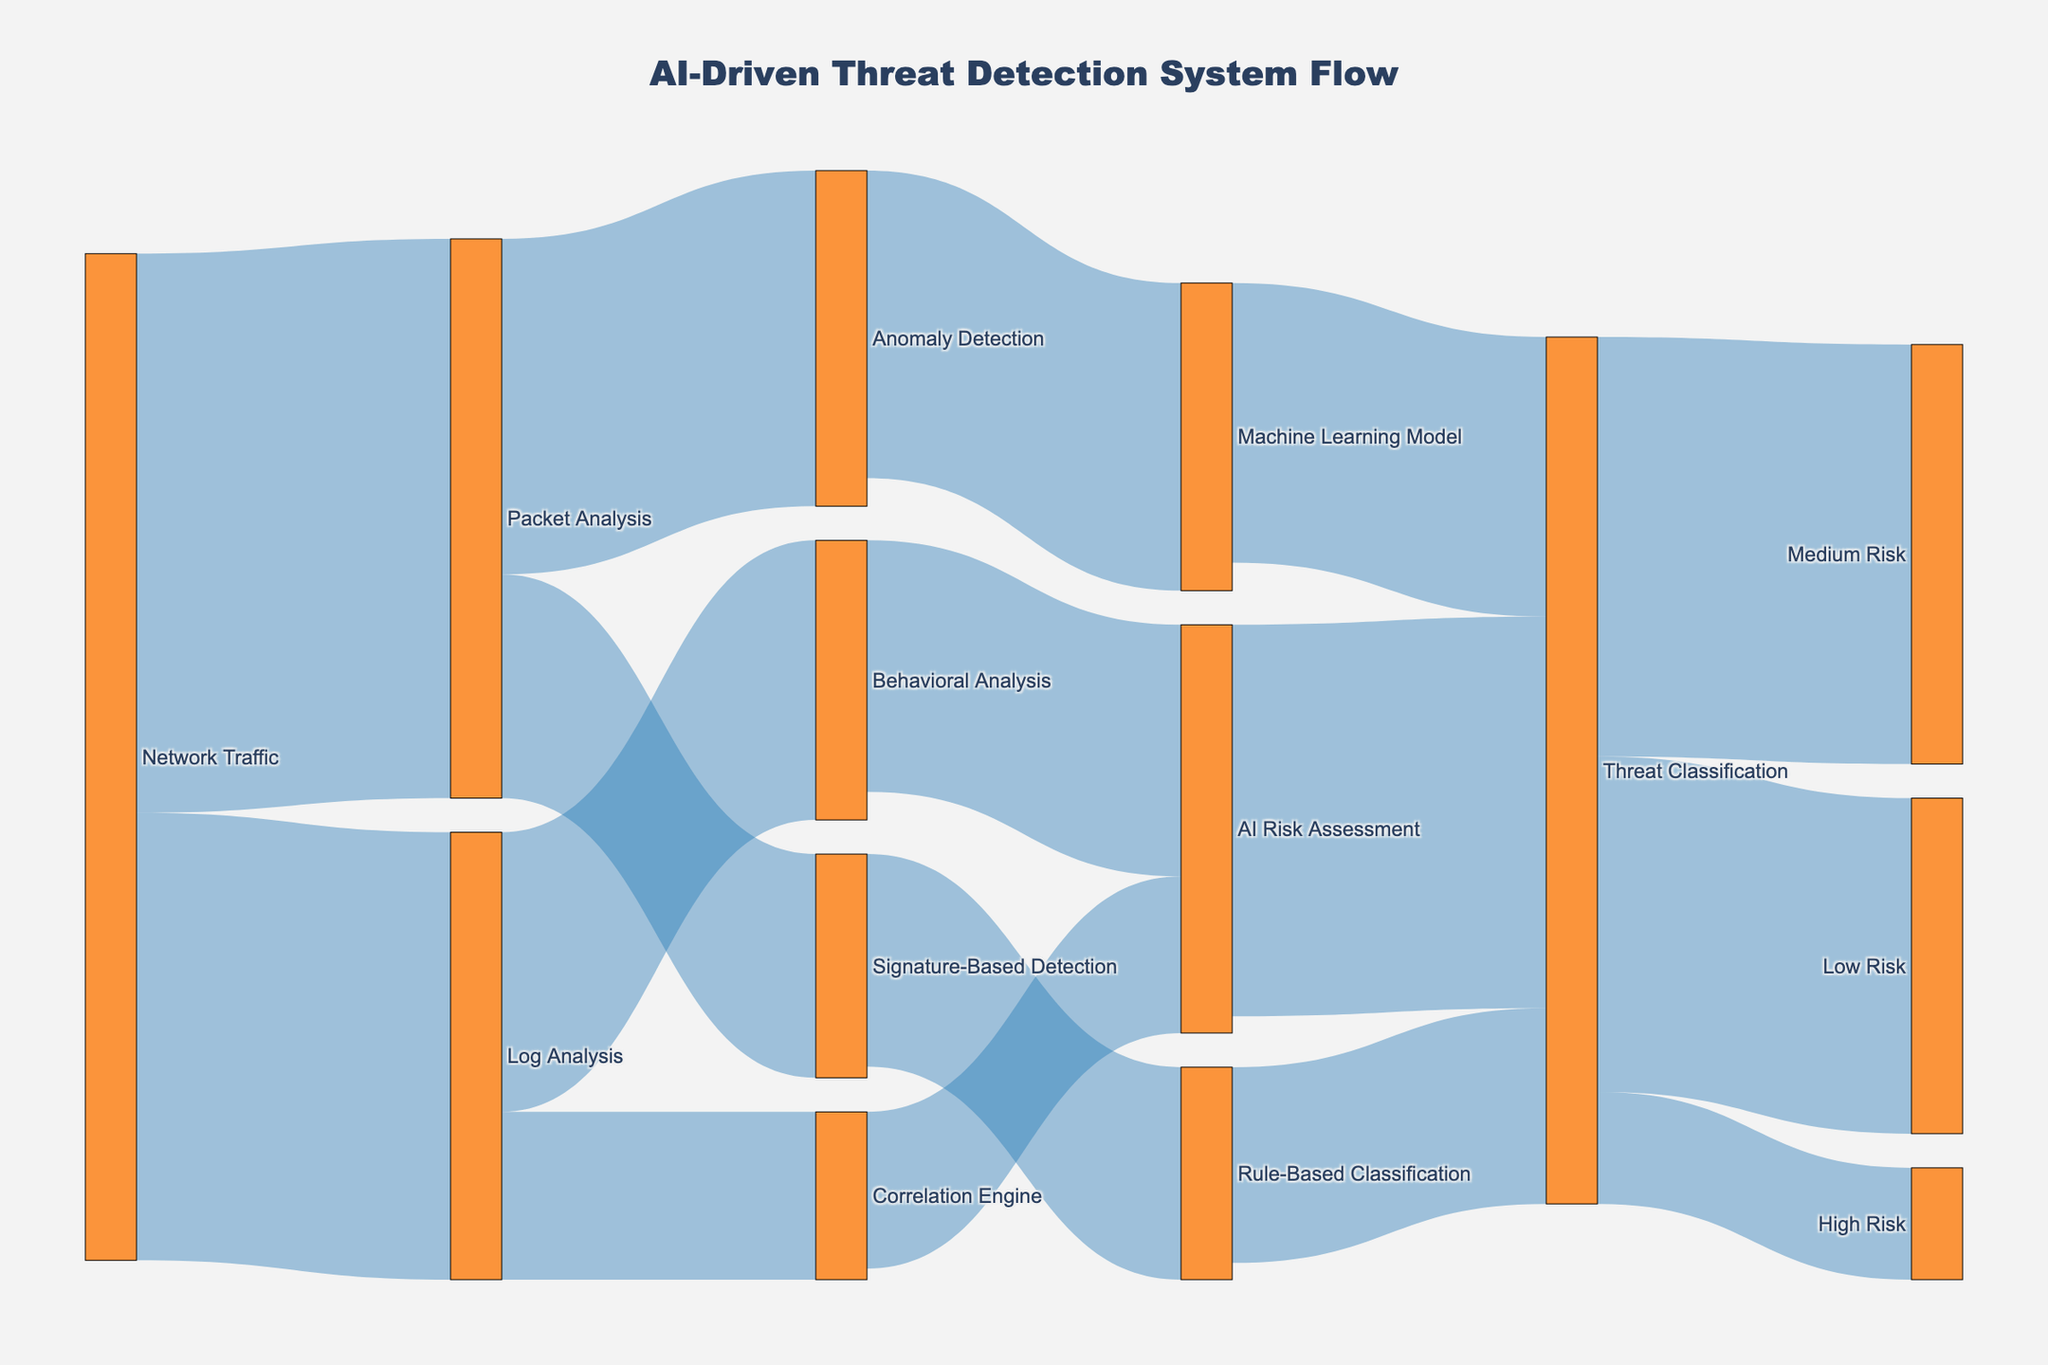What is the title of the diagram? The title is usually placed prominently at the top of the diagram. In this case, the title reads "AI-Driven Threat Detection System Flow."
Answer: AI-Driven Threat Detection System Flow Which data flow has the highest value entering the 'Threat Classification' node? Look at the arrows leading into the 'Threat Classification' node and compare their values. The highest value is 700 from 'AI Risk Assessment.'
Answer: Flow from AI Risk Assessment with value of 700 How many different types of threat classifications are there? Count the unique labels in the 'Threat Classification' node's outgoing flows. There are three classifications: 'Low Risk', 'Medium Risk', and 'High Risk.'
Answer: Three classifications What is the total value of flows originating from the 'Log Analysis' node? Sum the values of all outgoing flows from 'Log Analysis' (500 for 'Behavioral Analysis' and 300 for 'Correlation Engine'). The total is 800.
Answer: 800 Which path has the smallest value from initial input to final classification? Identify the paths and their values. One small path example is 'Log Analysis' to 'Correlation Engine' (300) and 'Correlation Engine' to 'AI Risk Assessment' (280).
Answer: Path: Log Analysis → Correlation Engine → AI Risk Assessment with 280 How does the flow from 'Network Traffic' to 'Anomaly Detection' compare to that from 'Network Traffic' to 'Log Analysis'? Compare the values from 'Network Traffic' to 'Anomaly Detection' (1000 -> 600) and to 'Log Analysis' (800). 'Log Analysis' is higher.
Answer: Log Analysis has a higher value (800 vs 600) What is the sum of values entering the 'AI Risk Assessment' node? Add the values entering 'AI Risk Assessment' from 'Behavioral Analysis' and 'Correlation Engine' (450 + 280). The sum is 730.
Answer: 730 Among the threat classifications, which risk category has the lowest value? Compare the values of 'Low Risk', 'Medium Risk', and 'High Risk'. The 'High Risk' category has the lowest value, which is 200.
Answer: High Risk Which node acts as the central hub between data inputs and threat classifications? Identify the node through which multiple paths converge into 'Threat Classification'. 'AI Risk Assessment' connects both 'Behavioral Analysis' and 'Correlation Engine' to 'Threat Classification.'
Answer: AI Risk Assessment What value flows from 'Anomaly Detection' to 'Machine Learning Model'? Look at the direct flow from 'Anomaly Detection' to 'Machine Learning Model'. The value is 550.
Answer: 550 